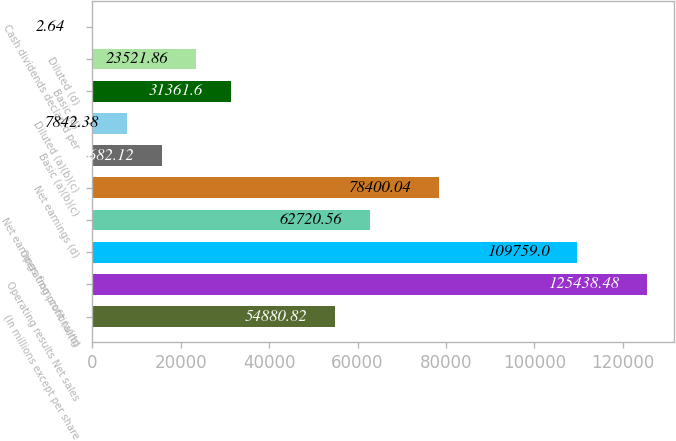Convert chart. <chart><loc_0><loc_0><loc_500><loc_500><bar_chart><fcel>(In millions except per share<fcel>Operating results Net sales<fcel>Operating profit (a)(b)<fcel>Net earnings from continuing<fcel>Net earnings (d)<fcel>Basic (a)(b)(c)<fcel>Diluted (a)(b)(c)<fcel>Basic (d)<fcel>Diluted (d)<fcel>Cash dividends declared per<nl><fcel>54880.8<fcel>125438<fcel>109759<fcel>62720.6<fcel>78400<fcel>15682.1<fcel>7842.38<fcel>31361.6<fcel>23521.9<fcel>2.64<nl></chart> 